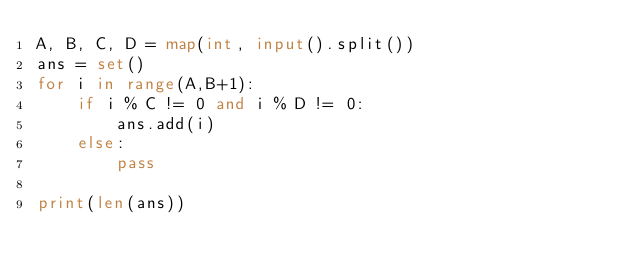<code> <loc_0><loc_0><loc_500><loc_500><_Python_>A, B, C, D = map(int, input().split())
ans = set()
for i in range(A,B+1):
    if i % C != 0 and i % D != 0:
        ans.add(i)
    else:
        pass

print(len(ans))</code> 